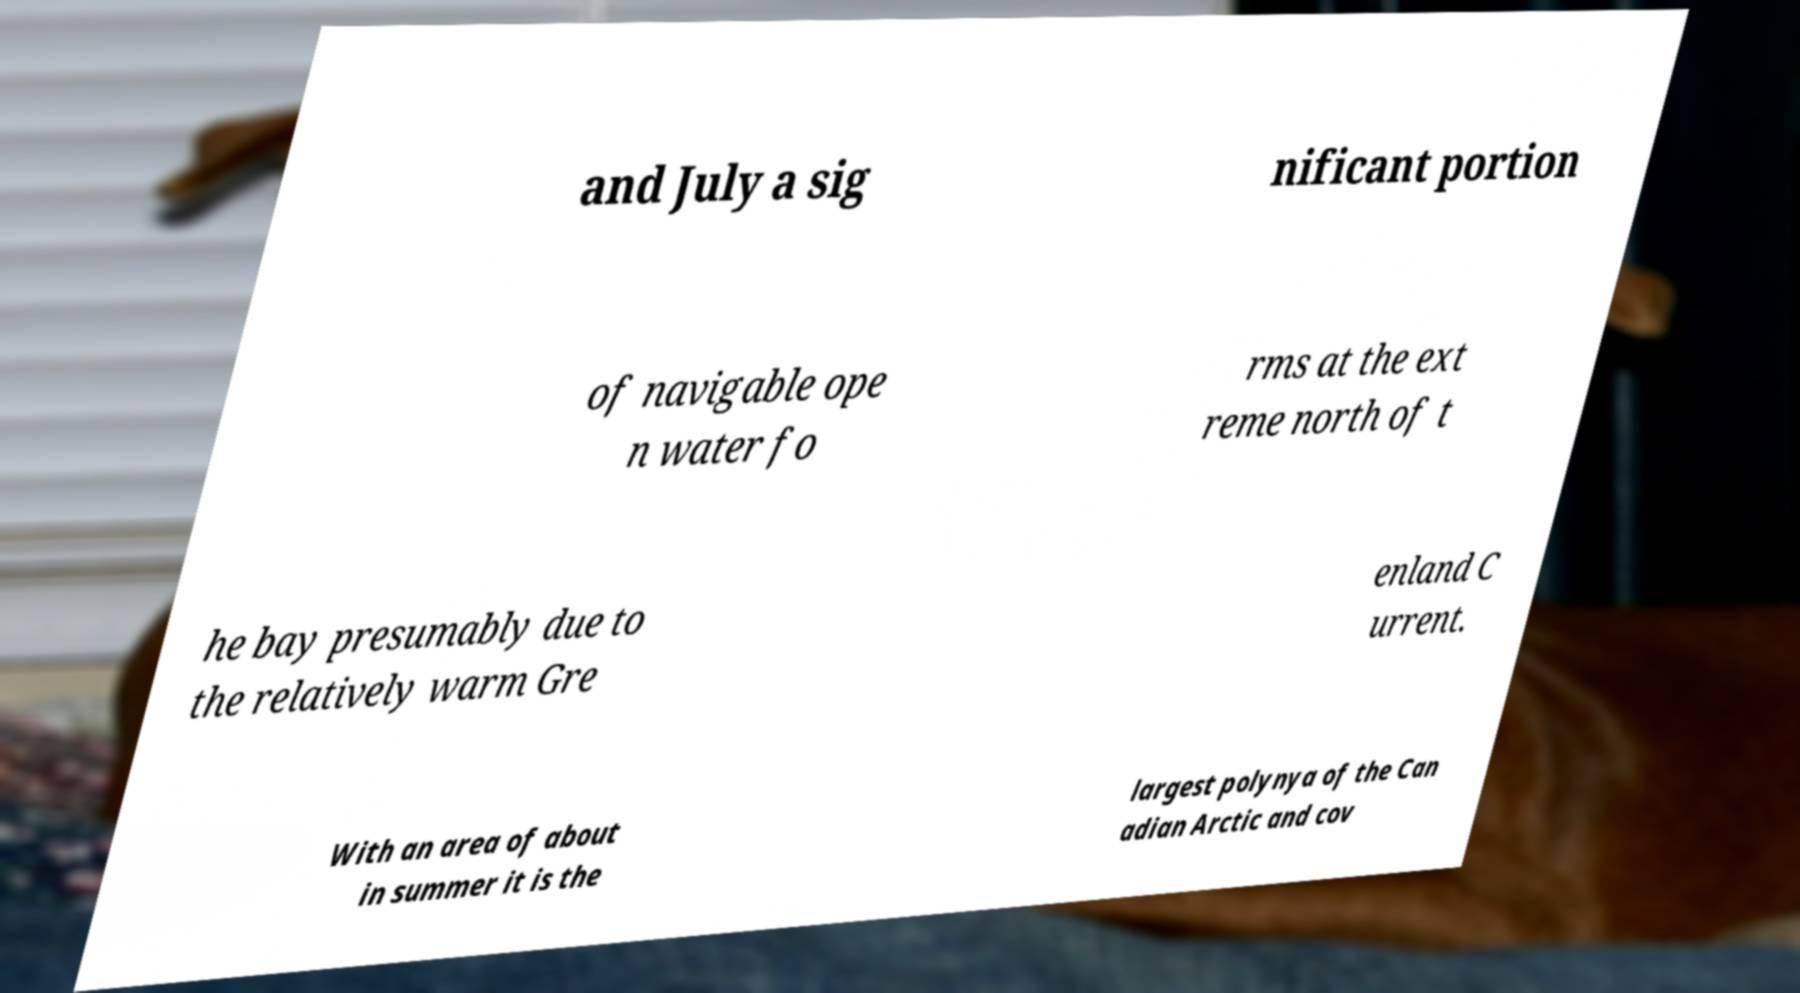Could you assist in decoding the text presented in this image and type it out clearly? and July a sig nificant portion of navigable ope n water fo rms at the ext reme north of t he bay presumably due to the relatively warm Gre enland C urrent. With an area of about in summer it is the largest polynya of the Can adian Arctic and cov 